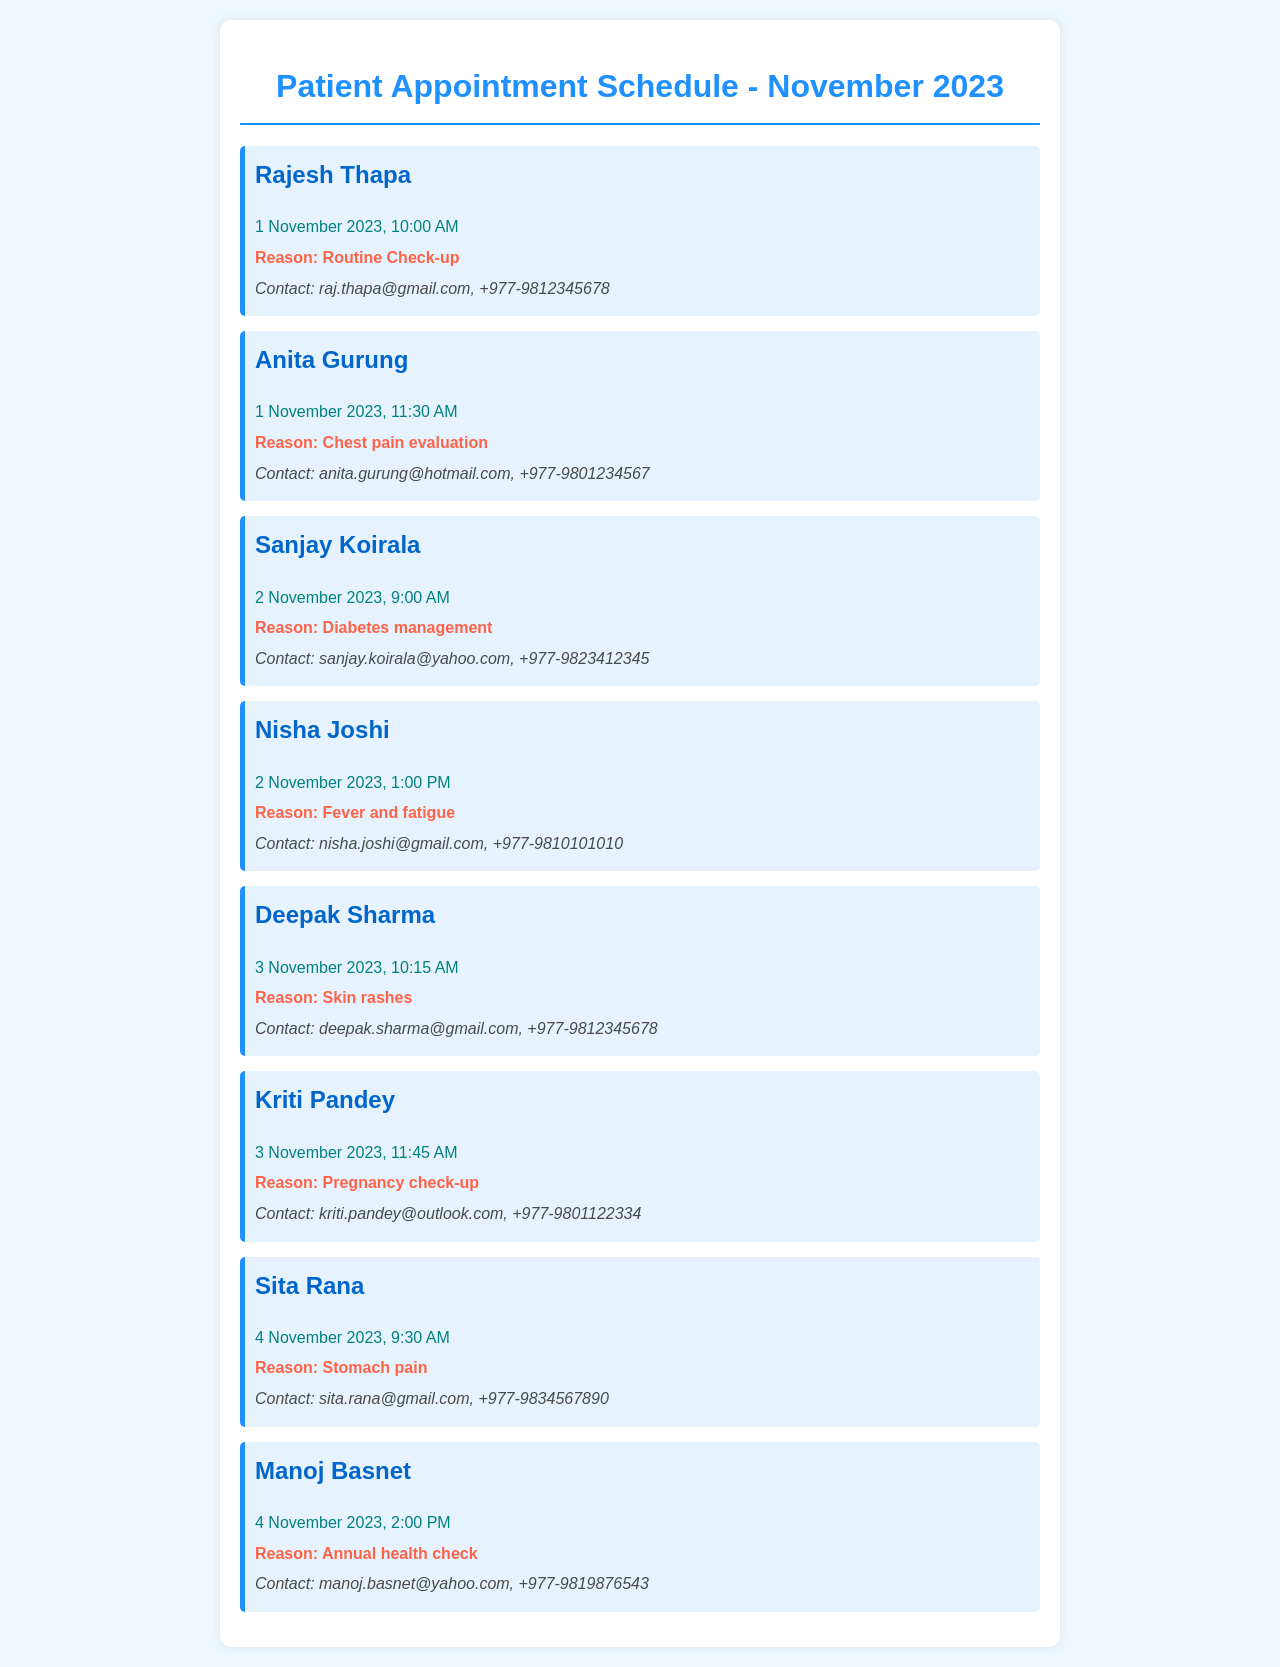What is the date of Rajesh Thapa's appointment? Rajesh Thapa's appointment is scheduled for 1 November 2023.
Answer: 1 November 2023 What is the reason for Anita Gurung's visit? The reason for Anita Gurung's visit is to evaluate chest pain.
Answer: Chest pain evaluation Who has an appointment on 3 November 2023 at 10:15 AM? The appointment at 10:15 AM on 3 November 2023 is for Deepak Sharma.
Answer: Deepak Sharma How many patients are scheduled on 2 November 2023? There are two patients scheduled on 2 November 2023: Sanjay Koirala and Nisha Joshi.
Answer: Two patients What is the contact information for Kriti Pandey? Kriti Pandey's contact information includes her email address and phone number.
Answer: kriti.pandey@outlook.com, +977-9801122334 What time is Manoj Basnet's appointment? Manoj Basnet's appointment is scheduled for 2:00 PM.
Answer: 2:00 PM Which patient is visiting for a pregnancy check-up? The patient visiting for a pregnancy check-up is Kriti Pandey.
Answer: Kriti Pandey How many appointments are scheduled for 1 November 2023? There are two appointments scheduled for 1 November 2023.
Answer: Two appointments What health issue does Sita Rana have? Sita Rana's health issue is stomach pain.
Answer: Stomach pain 